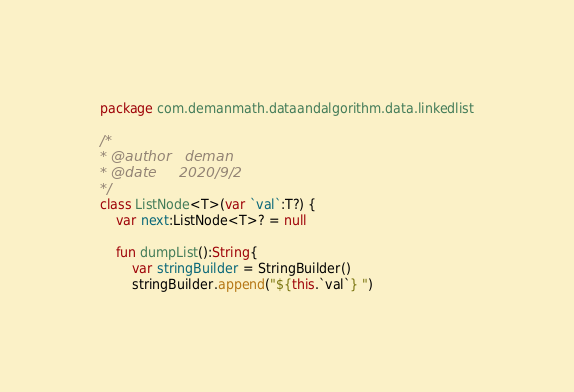Convert code to text. <code><loc_0><loc_0><loc_500><loc_500><_Kotlin_>package com.demanmath.dataandalgorithm.data.linkedlist

/*
* @author   deman
* @date     2020/9/2
*/
class ListNode<T>(var `val`:T?) {
    var next:ListNode<T>? = null

    fun dumpList():String{
        var stringBuilder = StringBuilder()
        stringBuilder.append("${this.`val`} ")</code> 